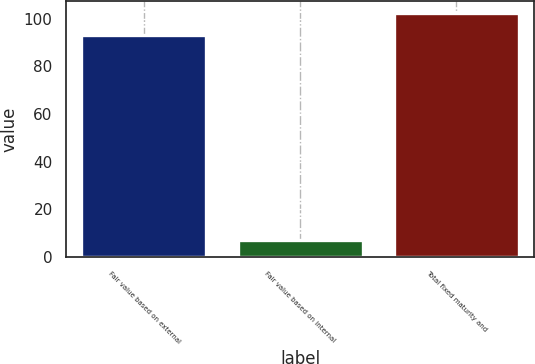Convert chart. <chart><loc_0><loc_0><loc_500><loc_500><bar_chart><fcel>Fair value based on external<fcel>Fair value based on internal<fcel>Total fixed maturity and<nl><fcel>93<fcel>7<fcel>102.3<nl></chart> 